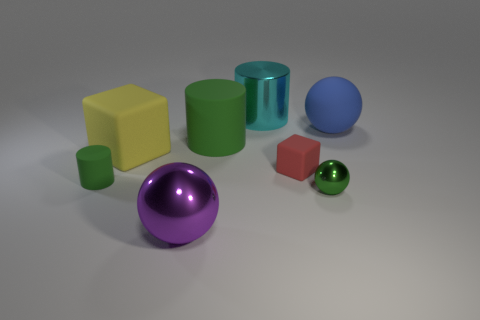Subtract all purple cylinders. Subtract all purple blocks. How many cylinders are left? 3 Add 1 big blue matte objects. How many objects exist? 9 Subtract all blocks. How many objects are left? 6 Subtract all small rubber blocks. Subtract all big shiny cylinders. How many objects are left? 6 Add 6 green cylinders. How many green cylinders are left? 8 Add 1 tiny purple metallic balls. How many tiny purple metallic balls exist? 1 Subtract 1 red blocks. How many objects are left? 7 